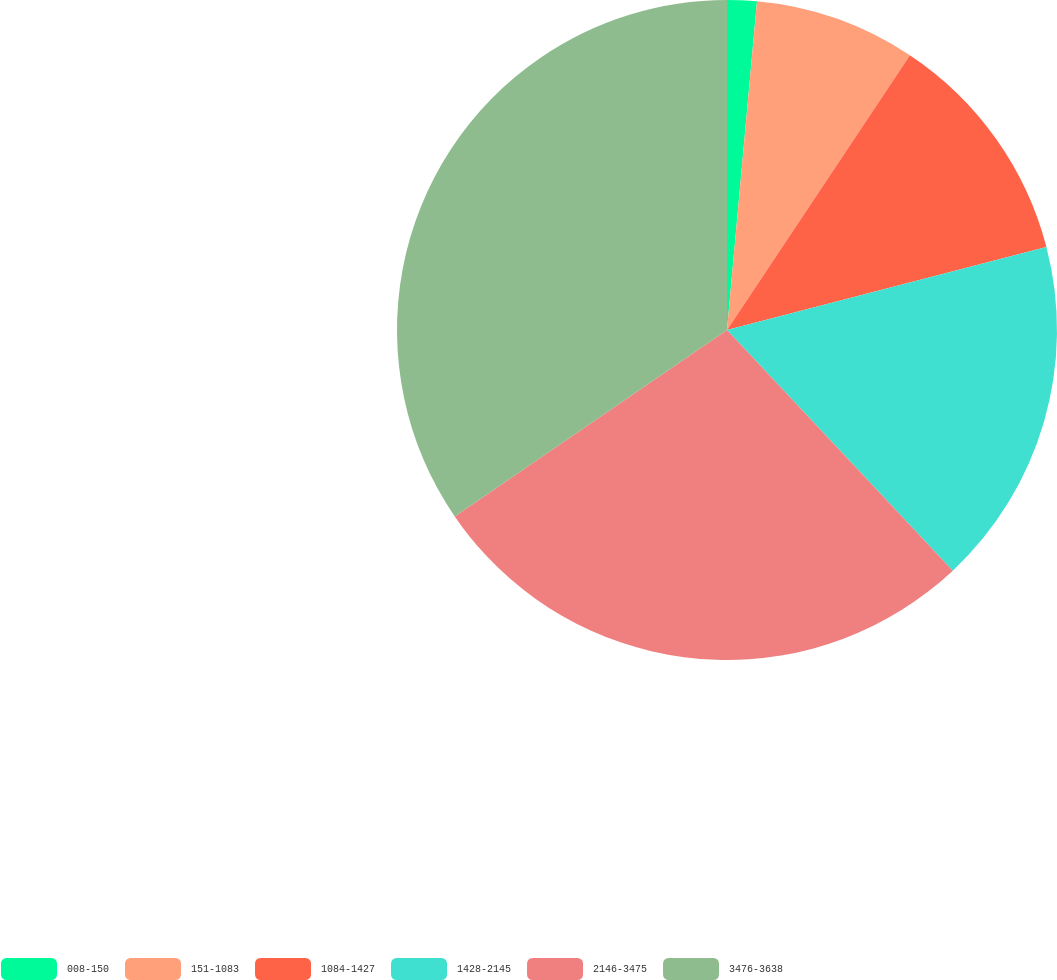<chart> <loc_0><loc_0><loc_500><loc_500><pie_chart><fcel>008-150<fcel>151-1083<fcel>1084-1427<fcel>1428-2145<fcel>2146-3475<fcel>3476-3638<nl><fcel>1.45%<fcel>7.9%<fcel>11.61%<fcel>17.05%<fcel>27.44%<fcel>34.56%<nl></chart> 